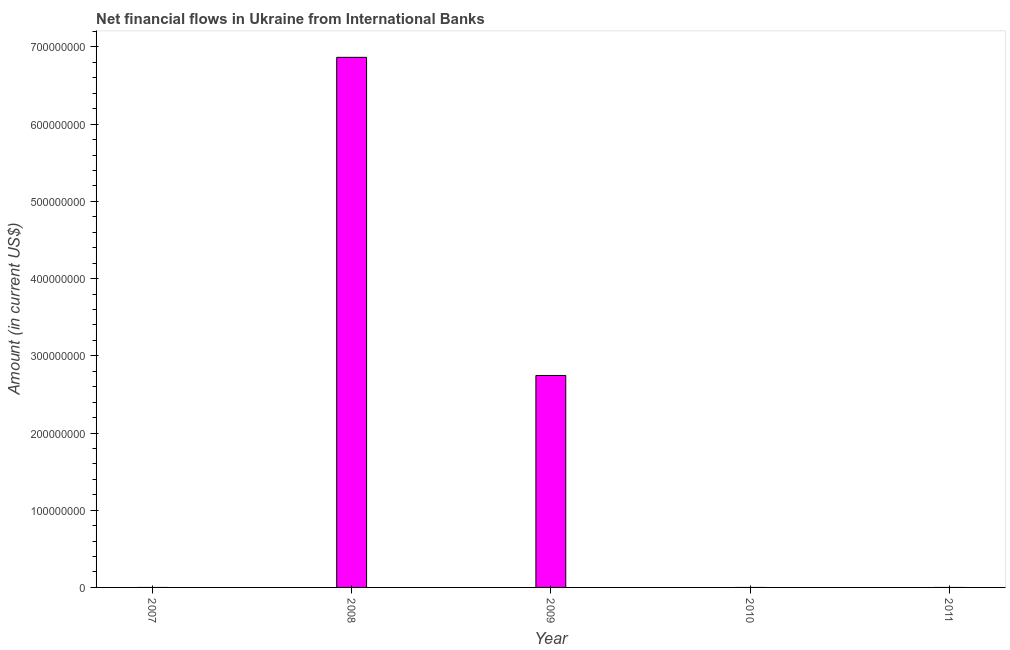Does the graph contain any zero values?
Offer a very short reply. Yes. Does the graph contain grids?
Make the answer very short. No. What is the title of the graph?
Ensure brevity in your answer.  Net financial flows in Ukraine from International Banks. What is the label or title of the X-axis?
Give a very brief answer. Year. What is the label or title of the Y-axis?
Your answer should be very brief. Amount (in current US$). What is the net financial flows from ibrd in 2011?
Give a very brief answer. 0. Across all years, what is the maximum net financial flows from ibrd?
Your response must be concise. 6.87e+08. In which year was the net financial flows from ibrd maximum?
Your answer should be compact. 2008. What is the sum of the net financial flows from ibrd?
Ensure brevity in your answer.  9.61e+08. What is the average net financial flows from ibrd per year?
Your answer should be compact. 1.92e+08. In how many years, is the net financial flows from ibrd greater than 560000000 US$?
Make the answer very short. 1. What is the ratio of the net financial flows from ibrd in 2008 to that in 2009?
Your answer should be very brief. 2.5. Is the sum of the net financial flows from ibrd in 2008 and 2009 greater than the maximum net financial flows from ibrd across all years?
Ensure brevity in your answer.  Yes. What is the difference between the highest and the lowest net financial flows from ibrd?
Provide a short and direct response. 6.87e+08. In how many years, is the net financial flows from ibrd greater than the average net financial flows from ibrd taken over all years?
Offer a terse response. 2. Are all the bars in the graph horizontal?
Keep it short and to the point. No. How many years are there in the graph?
Provide a short and direct response. 5. What is the difference between two consecutive major ticks on the Y-axis?
Ensure brevity in your answer.  1.00e+08. What is the Amount (in current US$) in 2007?
Keep it short and to the point. 0. What is the Amount (in current US$) in 2008?
Ensure brevity in your answer.  6.87e+08. What is the Amount (in current US$) of 2009?
Make the answer very short. 2.75e+08. What is the difference between the Amount (in current US$) in 2008 and 2009?
Give a very brief answer. 4.12e+08. What is the ratio of the Amount (in current US$) in 2008 to that in 2009?
Ensure brevity in your answer.  2.5. 